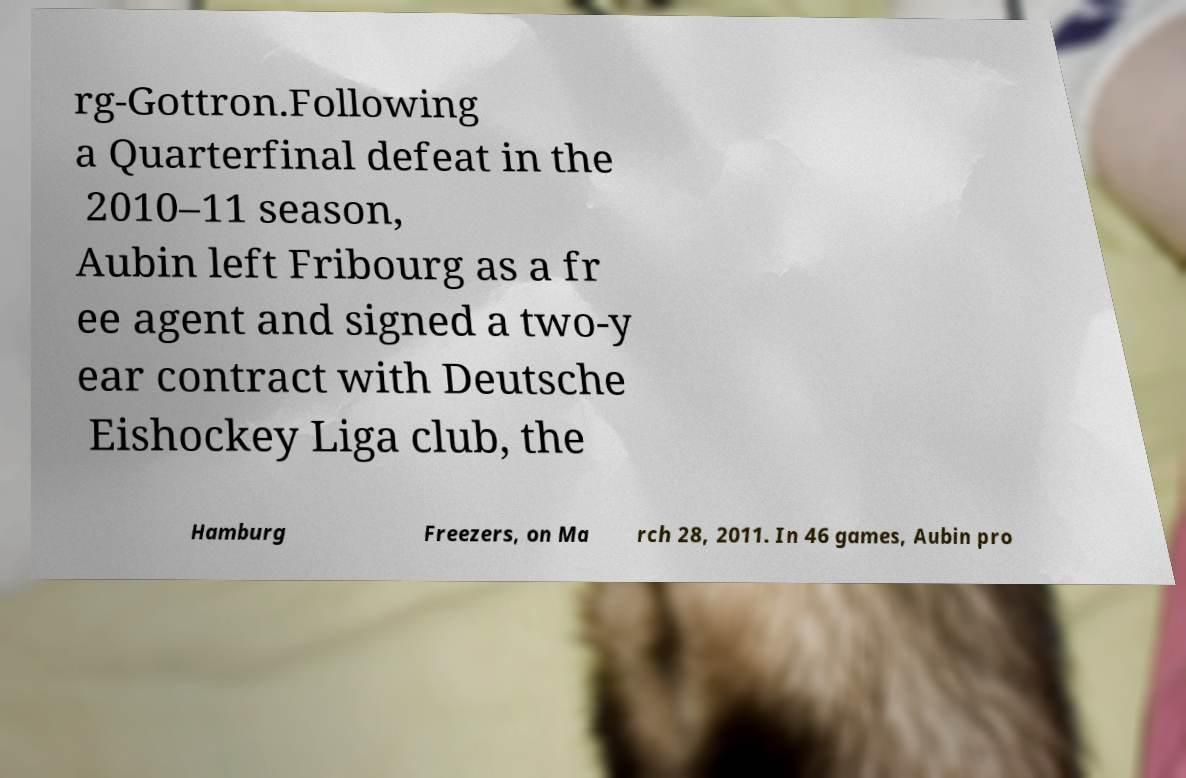Can you read and provide the text displayed in the image?This photo seems to have some interesting text. Can you extract and type it out for me? rg-Gottron.Following a Quarterfinal defeat in the 2010–11 season, Aubin left Fribourg as a fr ee agent and signed a two-y ear contract with Deutsche Eishockey Liga club, the Hamburg Freezers, on Ma rch 28, 2011. In 46 games, Aubin pro 